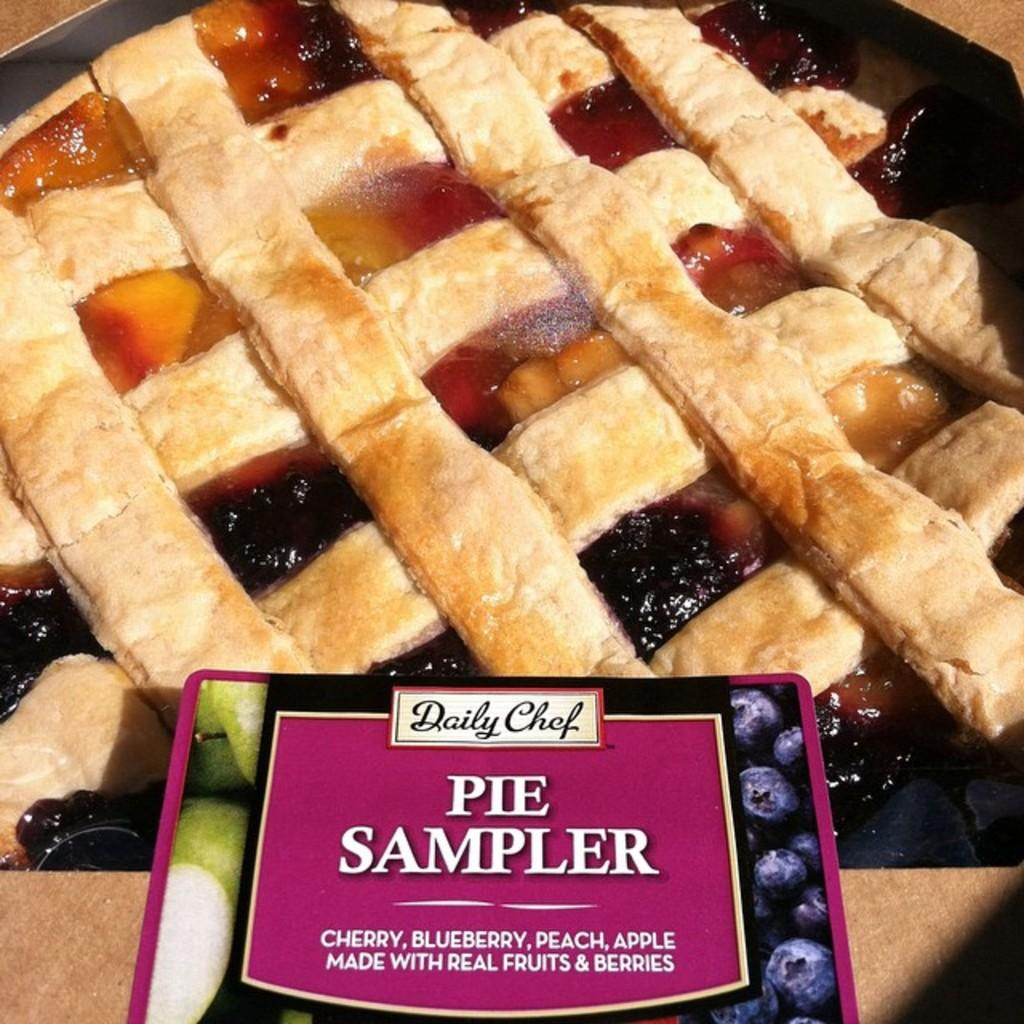What is the main subject of the image? The main subject of the image is food. How is the food arranged or presented in the image? The food is in a tray in the image. Are there any additional items or features in the image? Yes, there is a sticker in the image. What type of poison is visible on the food in the image? There is no poison present in the image; the food appears to be safe to consume. Can you describe the coastline visible in the image? There is no coastline present in the image; it features food in a tray and a sticker. 